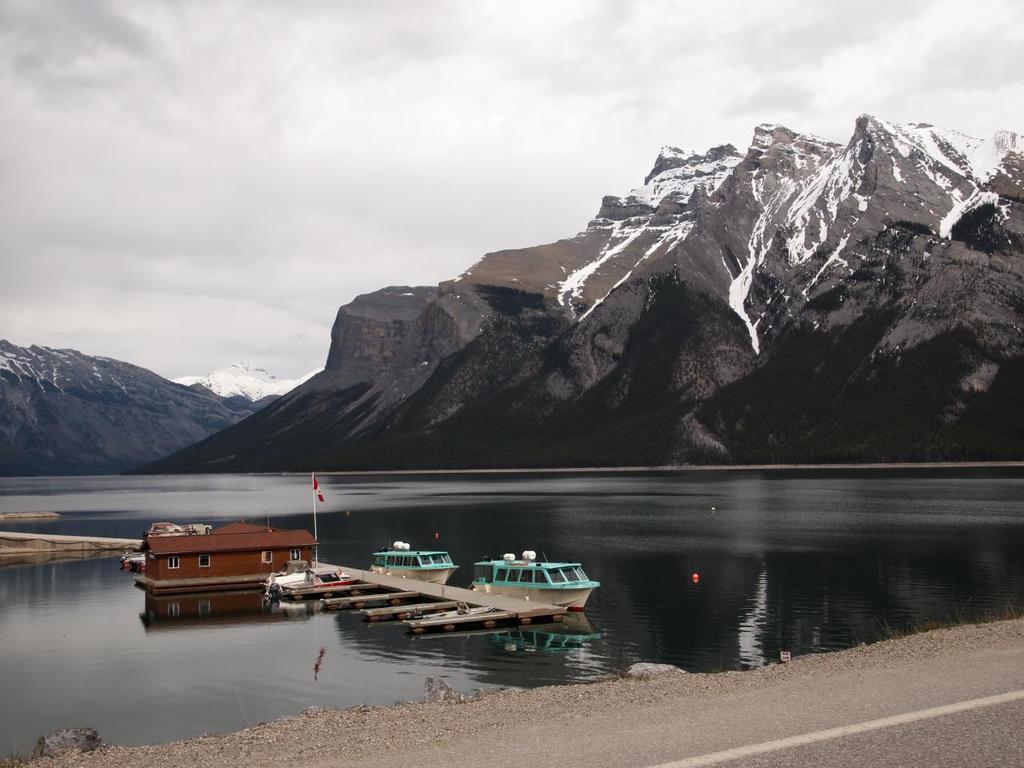Could you give a brief overview of what you see in this image? In this image we can see water. There is a deck. Near to the deck there is a building with windows and flag. There are boats on the water. In the back there are mountains with snow. Also there is sky with clouds. 